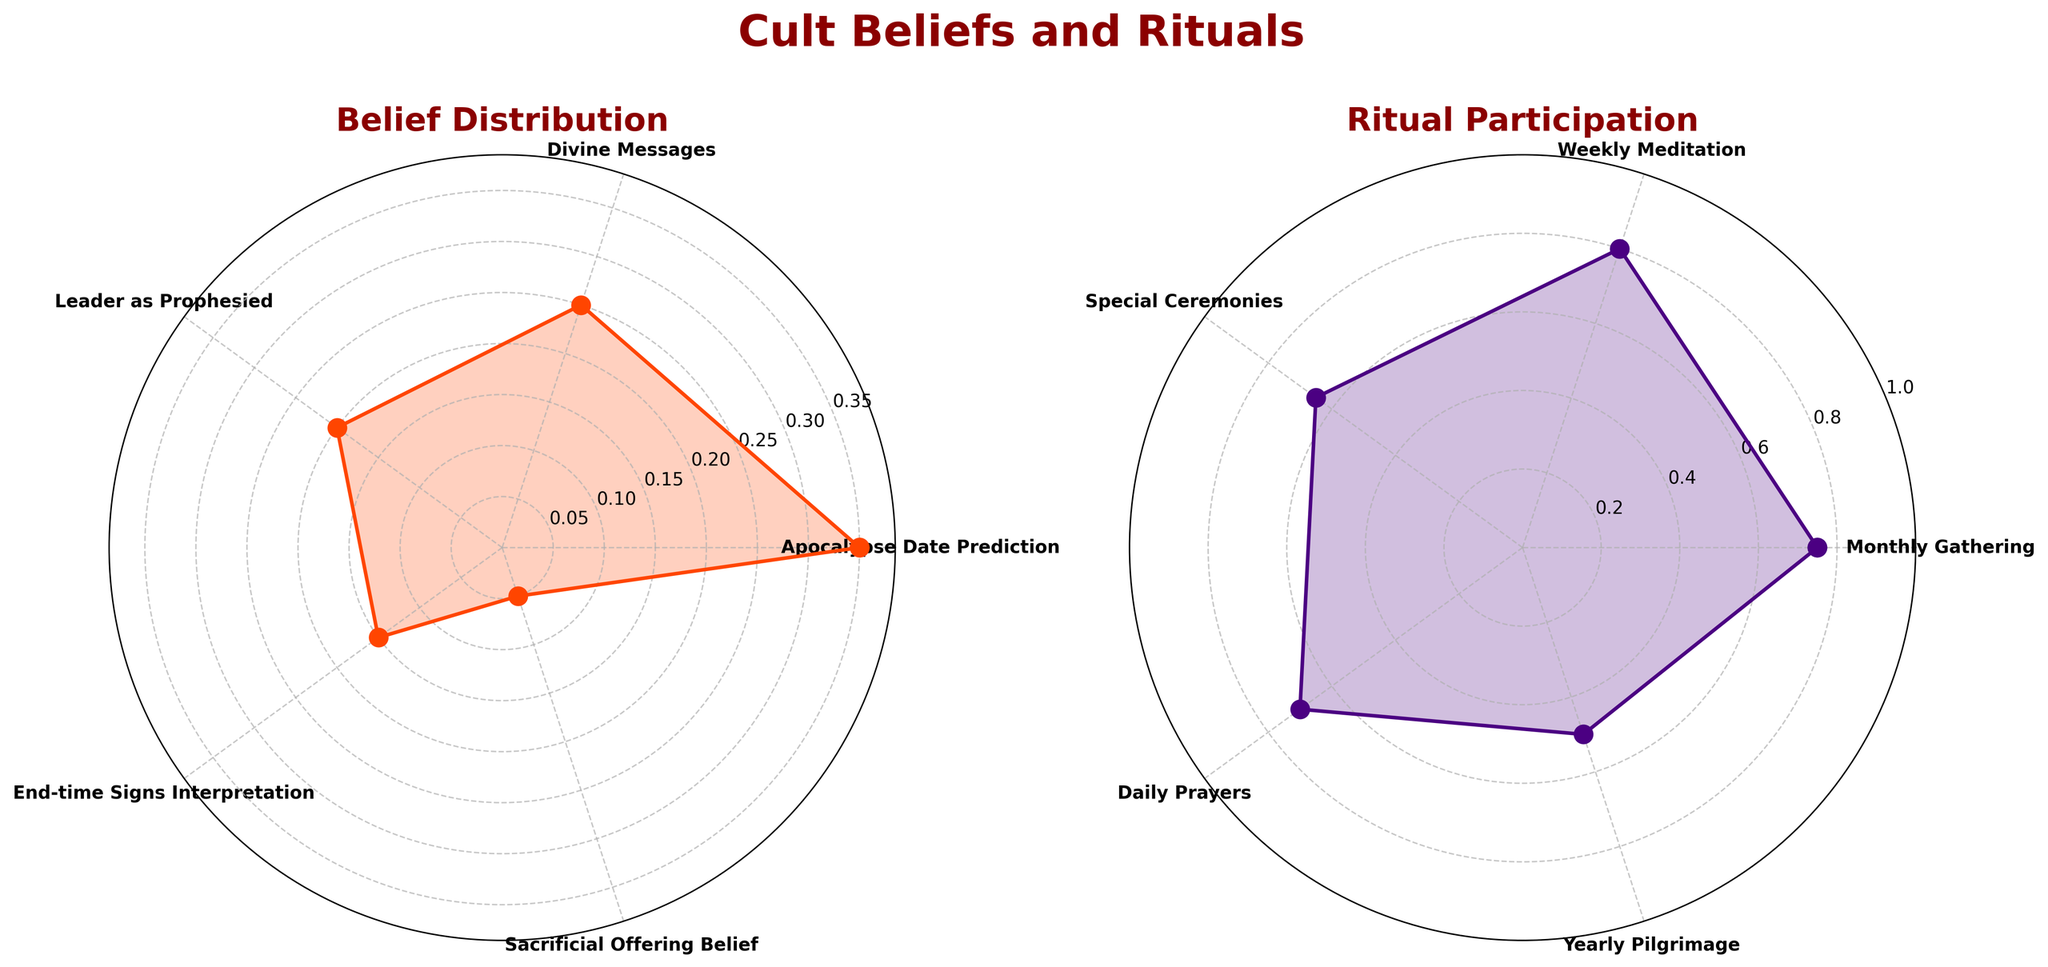What is the title of the figure? The figure has a main title displayed prominently above the subplots. Look at the center top of the figure to find the title.
Answer: Cult Beliefs and Rituals Which belief has the highest proportion among the members? The belief with the highest proportion can be identified by looking for the highest point on the left polar plot, which represents the belief distribution.
Answer: Apocalypse Date Prediction What is the participation rate for the Weekly Meditation ritual? To find the participation rate for this ritual, check the second subplot on the right and identify the point labeled as "Weekly Meditation" and the corresponding value on the radial axis.
Answer: 0.80 How much higher is the proportion of the belief in the Leader as Prophesied compared to the belief in Sacrificial Offering? Look at the left subplot to find the proportions for both beliefs and calculate the difference between the two values. The proportion for Leader as Prophesied is 0.20, and for Sacrificial Offering, it is 0.05.
Answer: 0.15 Which ritual has the lowest participation rate? On the right polar subplot, identify the lowest point on the plot, which indicates the lowest participation rate.
Answer: Yearly Pilgrimage What is the average participation rate for all the rituals? Add all the participation rates listed on the right polar plot and divide by the number of rituals. The participation rates are 0.75, 0.80, 0.65, 0.70, 0.50. Sum: 3.40. Divide by 5: 3.40 / 5 = 0.68.
Answer: 0.68 Between Monthly Gathering and Special Ceremonies, which ritual has a higher participation rate and by how much? Compare the participation rates for Monthly Gathering (0.75) and Special Ceremonies (0.65) on the right subplot and calculate the difference.
Answer: Monthly Gathering by 0.10 Which belief is characterized by the least proportion, and what is its value? On the left polar subplot, find the belief with the smallest proportion. This is the lowest point on the plot.
Answer: Sacrificial Offering Belief with 0.05 How does the participation rate of Daily Prayers compare to Weekly Meditation? Compare the values for Daily Prayers (0.70) and Weekly Meditation (0.80) on the right polar plot to determine if Daily Prayers is lower, higher, or equal.
Answer: Daily Prayers is 0.10 less than Weekly Meditation 